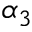<formula> <loc_0><loc_0><loc_500><loc_500>\alpha _ { 3 }</formula> 